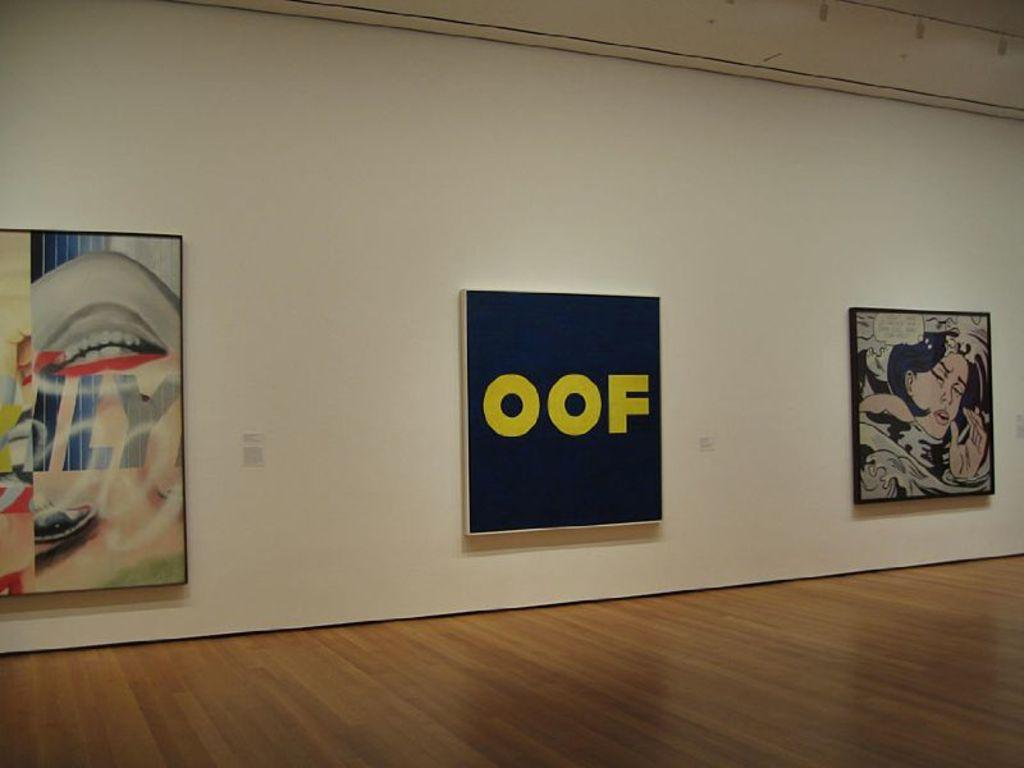What is at the bottom of the image? There is a floor at the bottom of the image. What can be seen in the middle of the image? There are frames attached to the wall in the middle of the image. What is the average income of the people in the image? There is no information about people or their income in the image. Can you tell me which airport is depicted in the image? There is no airport present in the image. 